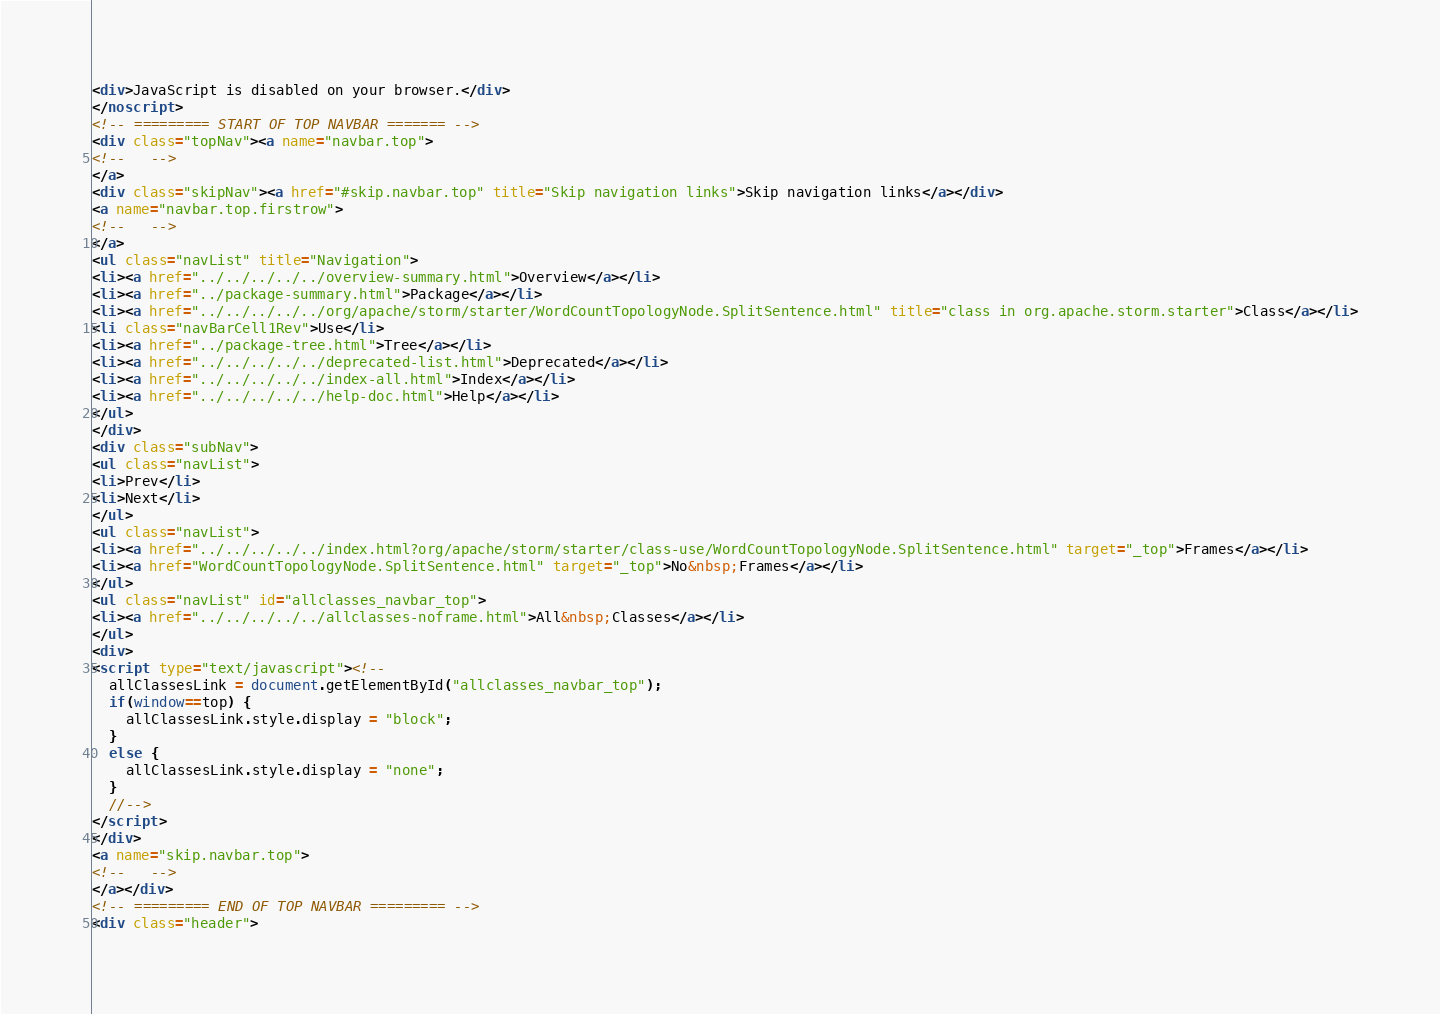Convert code to text. <code><loc_0><loc_0><loc_500><loc_500><_HTML_><div>JavaScript is disabled on your browser.</div>
</noscript>
<!-- ========= START OF TOP NAVBAR ======= -->
<div class="topNav"><a name="navbar.top">
<!--   -->
</a>
<div class="skipNav"><a href="#skip.navbar.top" title="Skip navigation links">Skip navigation links</a></div>
<a name="navbar.top.firstrow">
<!--   -->
</a>
<ul class="navList" title="Navigation">
<li><a href="../../../../../overview-summary.html">Overview</a></li>
<li><a href="../package-summary.html">Package</a></li>
<li><a href="../../../../../org/apache/storm/starter/WordCountTopologyNode.SplitSentence.html" title="class in org.apache.storm.starter">Class</a></li>
<li class="navBarCell1Rev">Use</li>
<li><a href="../package-tree.html">Tree</a></li>
<li><a href="../../../../../deprecated-list.html">Deprecated</a></li>
<li><a href="../../../../../index-all.html">Index</a></li>
<li><a href="../../../../../help-doc.html">Help</a></li>
</ul>
</div>
<div class="subNav">
<ul class="navList">
<li>Prev</li>
<li>Next</li>
</ul>
<ul class="navList">
<li><a href="../../../../../index.html?org/apache/storm/starter/class-use/WordCountTopologyNode.SplitSentence.html" target="_top">Frames</a></li>
<li><a href="WordCountTopologyNode.SplitSentence.html" target="_top">No&nbsp;Frames</a></li>
</ul>
<ul class="navList" id="allclasses_navbar_top">
<li><a href="../../../../../allclasses-noframe.html">All&nbsp;Classes</a></li>
</ul>
<div>
<script type="text/javascript"><!--
  allClassesLink = document.getElementById("allclasses_navbar_top");
  if(window==top) {
    allClassesLink.style.display = "block";
  }
  else {
    allClassesLink.style.display = "none";
  }
  //-->
</script>
</div>
<a name="skip.navbar.top">
<!--   -->
</a></div>
<!-- ========= END OF TOP NAVBAR ========= -->
<div class="header"></code> 